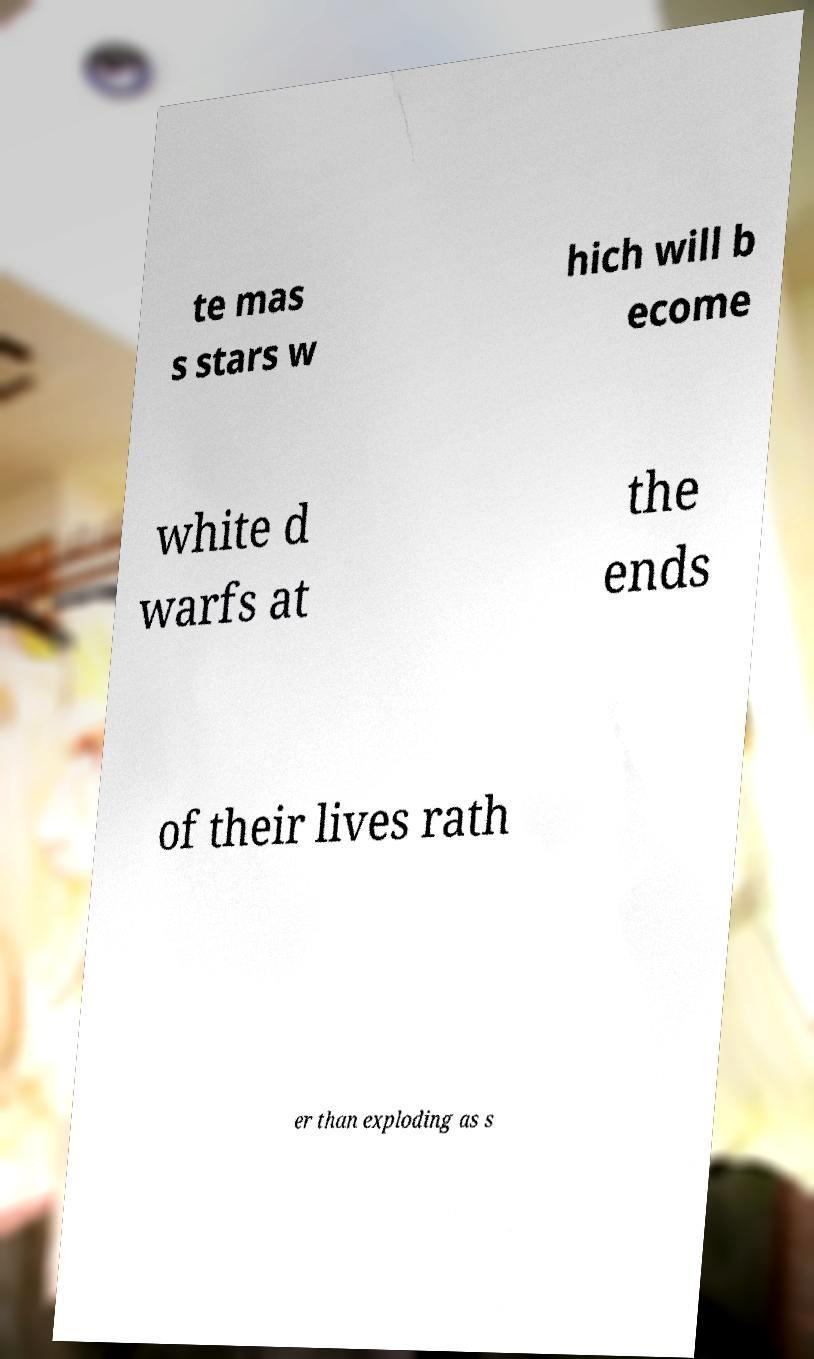There's text embedded in this image that I need extracted. Can you transcribe it verbatim? te mas s stars w hich will b ecome white d warfs at the ends of their lives rath er than exploding as s 